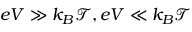<formula> <loc_0><loc_0><loc_500><loc_500>e V \gg k _ { B } \mathcal { T } , e V \ll k _ { B } \mathcal { T }</formula> 